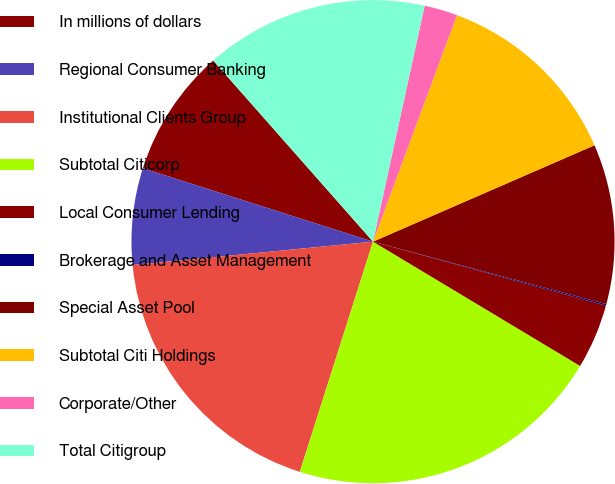Convert chart. <chart><loc_0><loc_0><loc_500><loc_500><pie_chart><fcel>In millions of dollars<fcel>Regional Consumer Banking<fcel>Institutional Clients Group<fcel>Subtotal Citicorp<fcel>Local Consumer Lending<fcel>Brokerage and Asset Management<fcel>Special Asset Pool<fcel>Subtotal Citi Holdings<fcel>Corporate/Other<fcel>Total Citigroup<nl><fcel>8.58%<fcel>6.46%<fcel>18.56%<fcel>21.3%<fcel>4.34%<fcel>0.1%<fcel>10.7%<fcel>12.82%<fcel>2.22%<fcel>14.94%<nl></chart> 